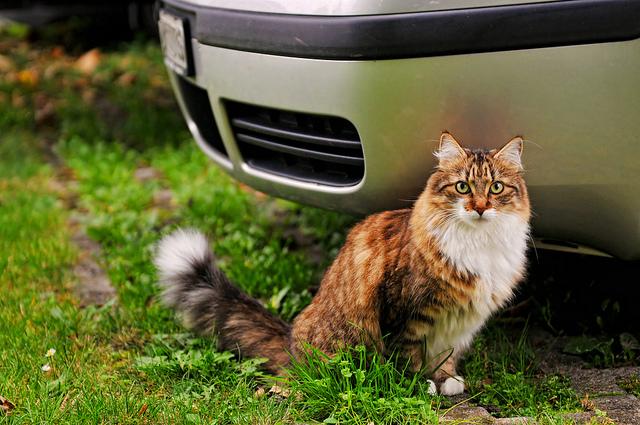Does this cat have short hair?
Quick response, please. No. Does the cat seem overweight?
Answer briefly. No. What color is the grass?
Be succinct. Green. What is the cat standing on?
Concise answer only. Grass. What color is the tip of this cat's tail?
Keep it brief. White. 